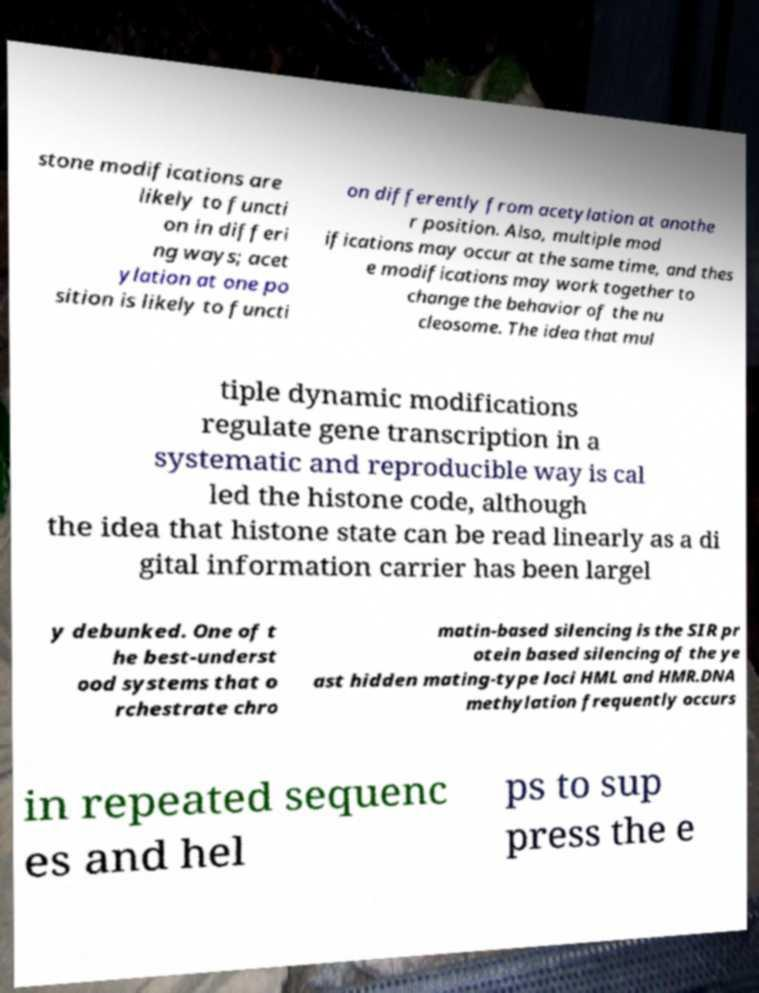Can you read and provide the text displayed in the image?This photo seems to have some interesting text. Can you extract and type it out for me? stone modifications are likely to functi on in differi ng ways; acet ylation at one po sition is likely to functi on differently from acetylation at anothe r position. Also, multiple mod ifications may occur at the same time, and thes e modifications may work together to change the behavior of the nu cleosome. The idea that mul tiple dynamic modifications regulate gene transcription in a systematic and reproducible way is cal led the histone code, although the idea that histone state can be read linearly as a di gital information carrier has been largel y debunked. One of t he best-underst ood systems that o rchestrate chro matin-based silencing is the SIR pr otein based silencing of the ye ast hidden mating-type loci HML and HMR.DNA methylation frequently occurs in repeated sequenc es and hel ps to sup press the e 